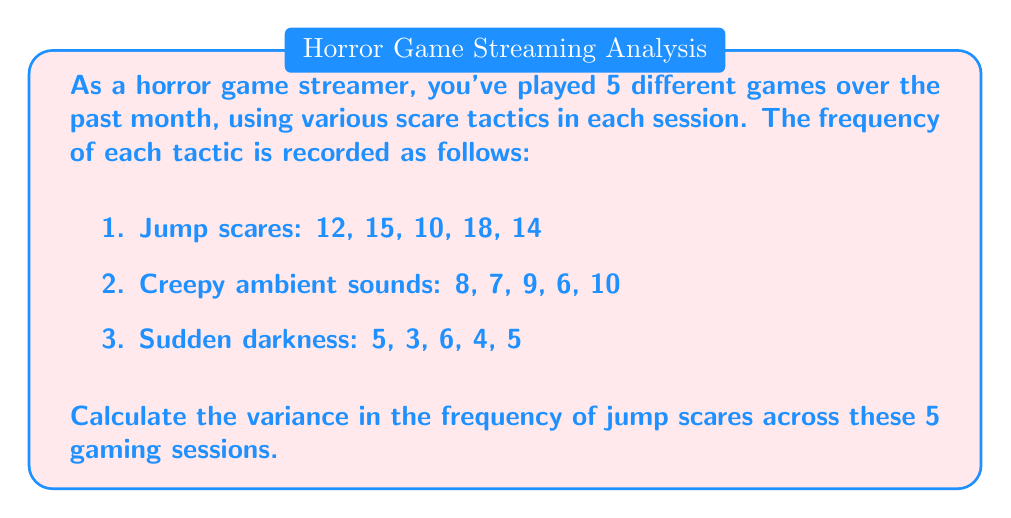What is the answer to this math problem? To calculate the variance of jump scares, we'll follow these steps:

1. Calculate the mean (average) of jump scares:
   $\mu = \frac{12 + 15 + 10 + 18 + 14}{5} = \frac{69}{5} = 13.8$

2. Calculate the squared differences from the mean:
   $(12 - 13.8)^2 = (-1.8)^2 = 3.24$
   $(15 - 13.8)^2 = (1.2)^2 = 1.44$
   $(10 - 13.8)^2 = (-3.8)^2 = 14.44$
   $(18 - 13.8)^2 = (4.2)^2 = 17.64$
   $(14 - 13.8)^2 = (0.2)^2 = 0.04$

3. Sum the squared differences:
   $3.24 + 1.44 + 14.44 + 17.64 + 0.04 = 36.8$

4. Divide by the number of sessions (5) to get the variance:
   $\text{Variance} = \frac{36.8}{5} = 7.36$

Therefore, the variance in the frequency of jump scares is 7.36.
Answer: 7.36 